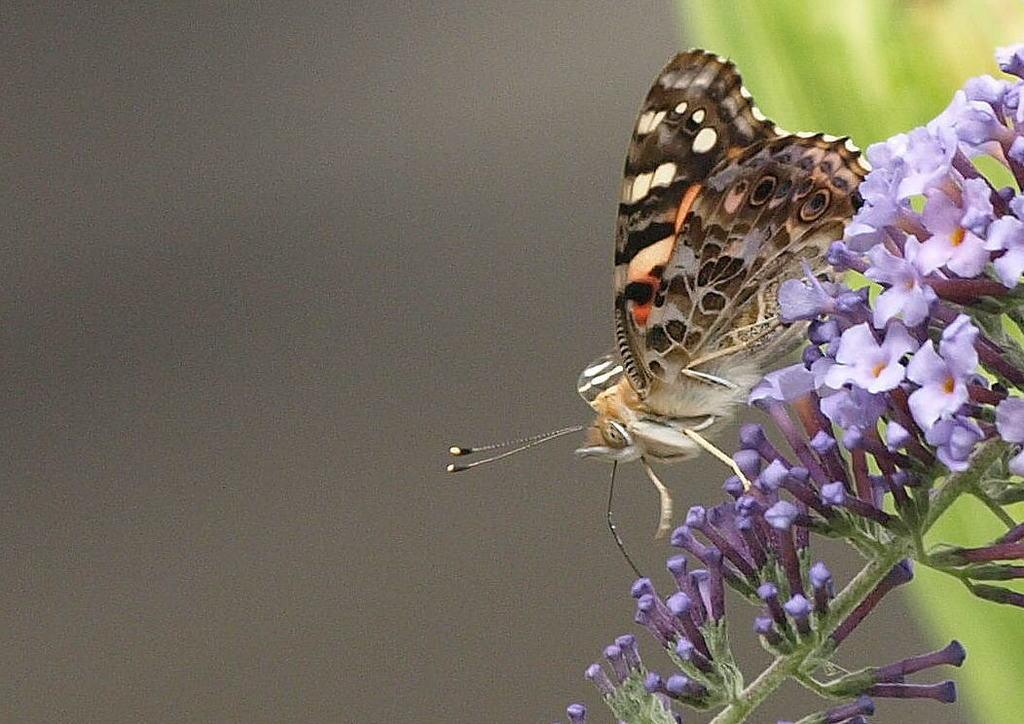What is the main subject of the picture? The main subject of the picture is a butterfly. What is the butterfly doing in the picture? The butterfly is standing on a flower. What color are the flowers in the picture? The flowers in the picture are purple. What else can be seen in the picture besides the butterfly and flowers? There is a plant in the picture. What type of medical condition does the butterfly have in the image? There is no indication of any medical condition in the image, as it features a butterfly standing on a flower. What substance is the butterfly using to stand on the flower in the image? Butterflies do not use any substance to stand on flowers; they have specialized feet called tarsi that allow them to grip onto surfaces. 